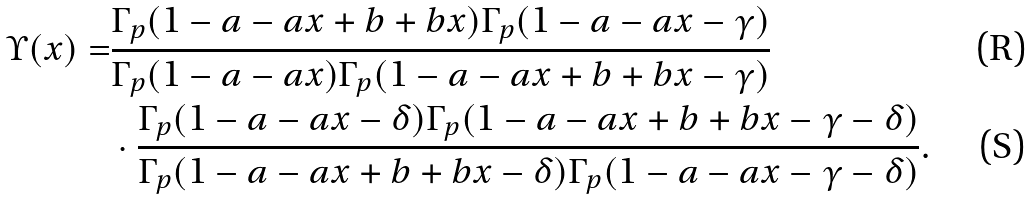<formula> <loc_0><loc_0><loc_500><loc_500>\Upsilon ( x ) = & \frac { \Gamma _ { p } ( 1 - a - a x + b + b x ) \Gamma _ { p } ( 1 - a - a x - \gamma ) } { \Gamma _ { p } ( 1 - a - a x ) \Gamma _ { p } ( 1 - a - a x + b + b x - \gamma ) } \\ & \cdot \frac { \Gamma _ { p } ( 1 - a - a x - \delta ) \Gamma _ { p } ( 1 - a - a x + b + b x - \gamma - \delta ) } { \Gamma _ { p } ( 1 - a - a x + b + b x - \delta ) \Gamma _ { p } ( 1 - a - a x - \gamma - \delta ) } .</formula> 